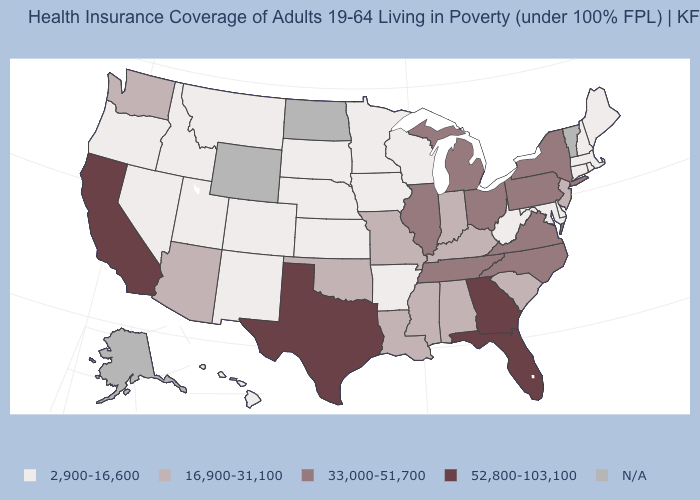What is the value of Delaware?
Keep it brief. 2,900-16,600. Which states have the highest value in the USA?
Short answer required. California, Florida, Georgia, Texas. Which states hav the highest value in the West?
Give a very brief answer. California. What is the value of Hawaii?
Be succinct. 2,900-16,600. What is the lowest value in the USA?
Write a very short answer. 2,900-16,600. What is the lowest value in the USA?
Be succinct. 2,900-16,600. What is the lowest value in the Northeast?
Be succinct. 2,900-16,600. Does the map have missing data?
Keep it brief. Yes. What is the value of Alabama?
Give a very brief answer. 16,900-31,100. Is the legend a continuous bar?
Give a very brief answer. No. What is the value of Vermont?
Concise answer only. N/A. What is the lowest value in the MidWest?
Be succinct. 2,900-16,600. Name the states that have a value in the range 52,800-103,100?
Quick response, please. California, Florida, Georgia, Texas. What is the value of Virginia?
Give a very brief answer. 33,000-51,700. Among the states that border Minnesota , which have the highest value?
Write a very short answer. Iowa, South Dakota, Wisconsin. 